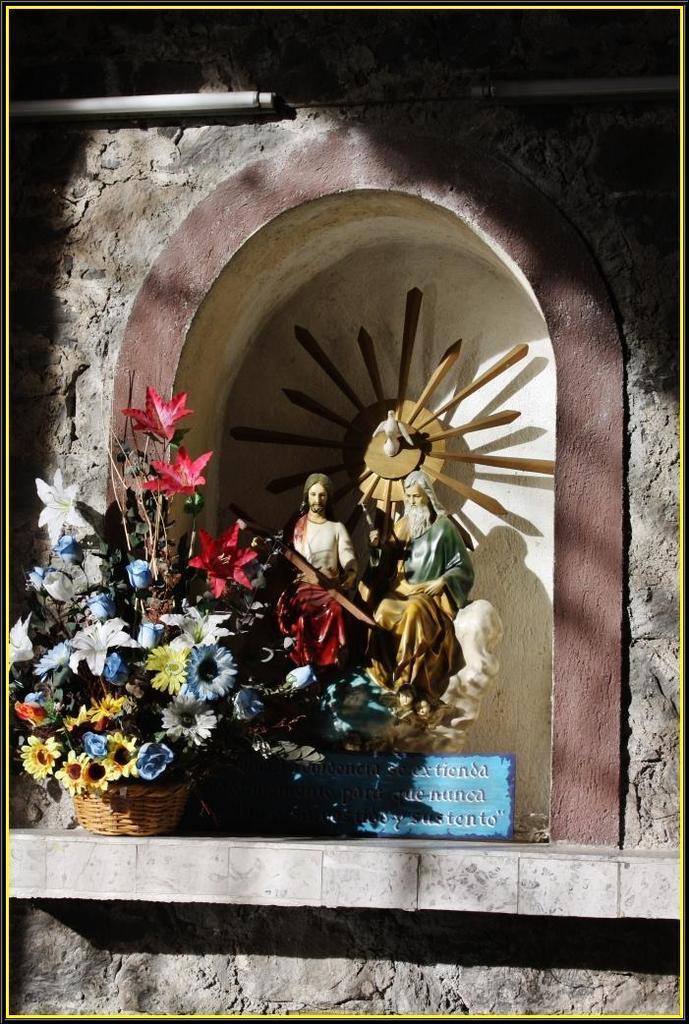Could you give a brief overview of what you see in this image? In this picture we can see statues, board, flower bouquet, basket, lights, and wall. 